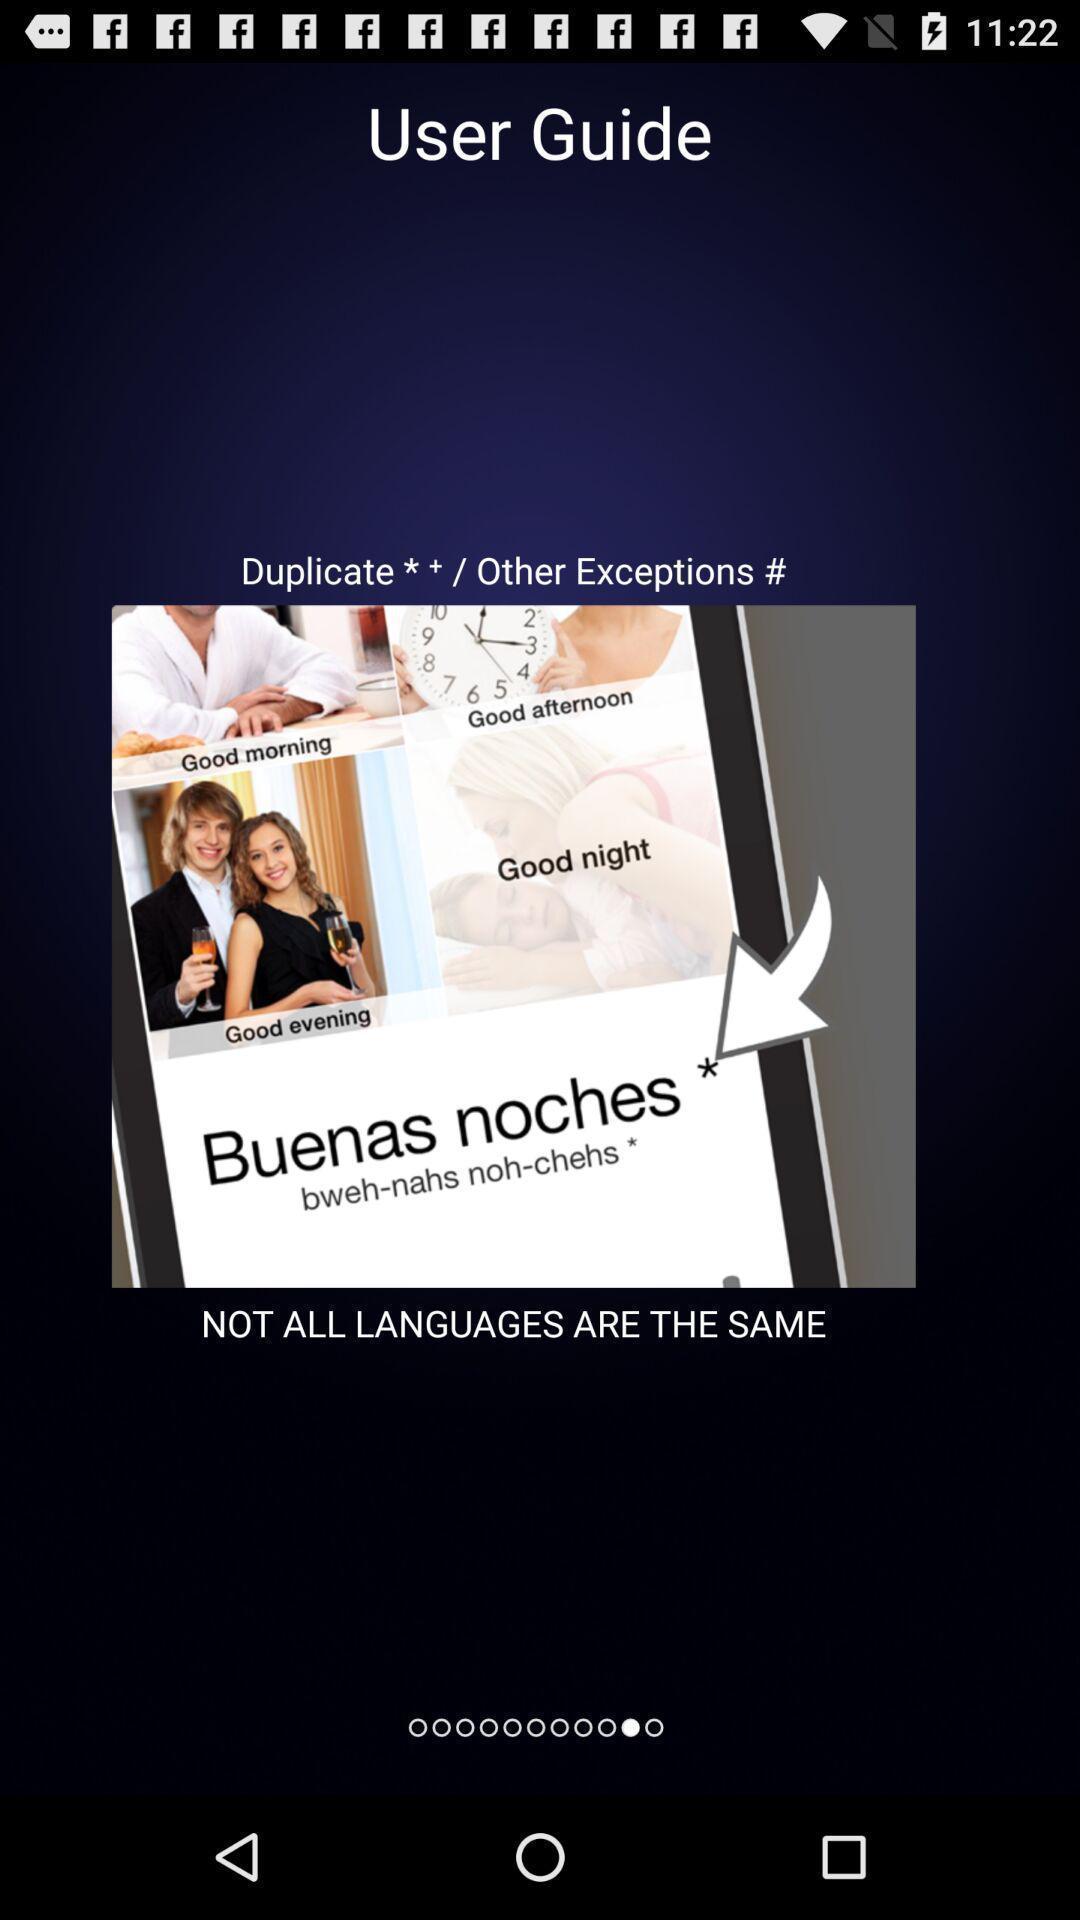Describe the key features of this screenshot. Screen shows user guide page. 